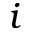<formula> <loc_0><loc_0><loc_500><loc_500>i</formula> 